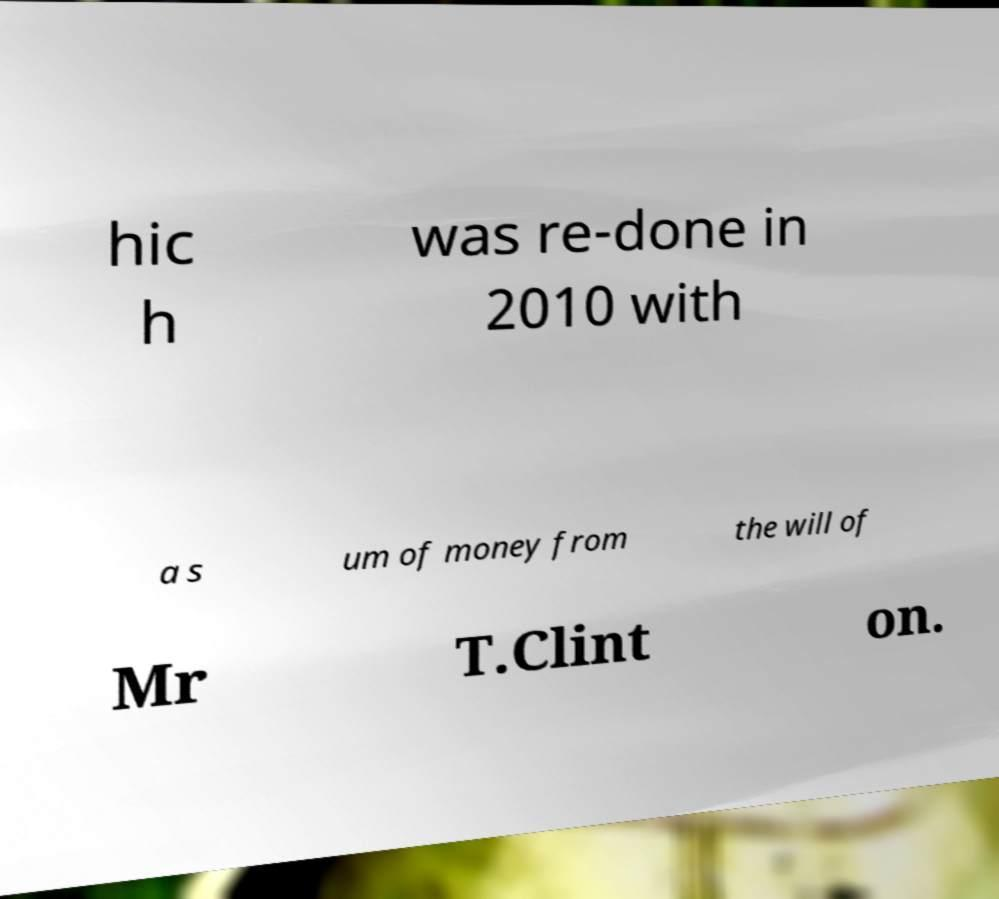There's text embedded in this image that I need extracted. Can you transcribe it verbatim? hic h was re-done in 2010 with a s um of money from the will of Mr T.Clint on. 